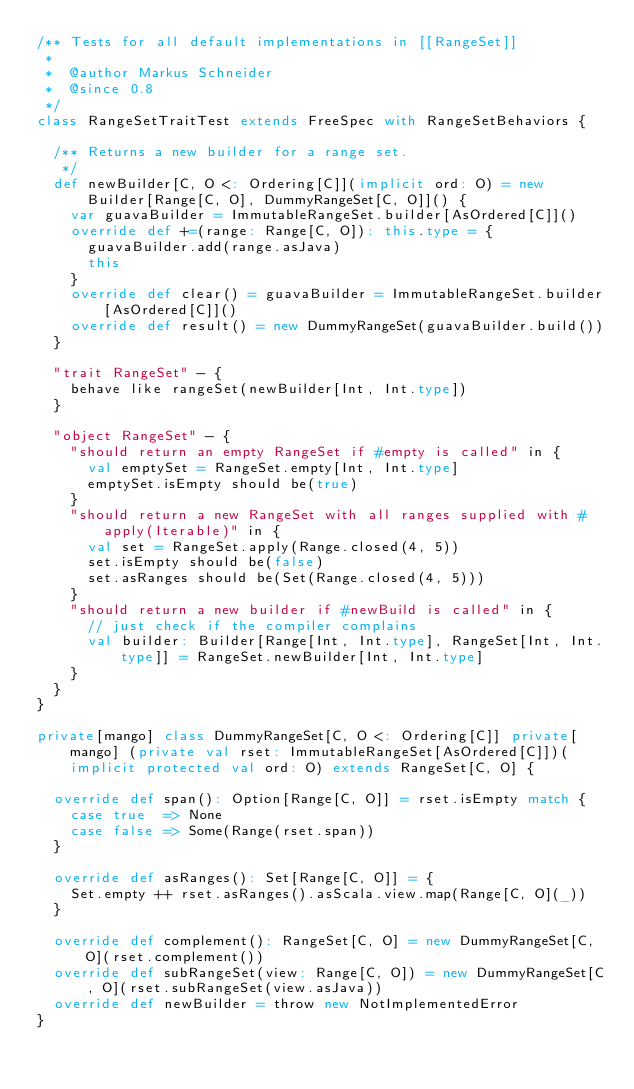Convert code to text. <code><loc_0><loc_0><loc_500><loc_500><_Scala_>/** Tests for all default implementations in [[RangeSet]]
 *
 *  @author Markus Schneider
 *  @since 0.8
 */
class RangeSetTraitTest extends FreeSpec with RangeSetBehaviors {

  /** Returns a new builder for a range set.
   */
  def newBuilder[C, O <: Ordering[C]](implicit ord: O) = new Builder[Range[C, O], DummyRangeSet[C, O]]() {
    var guavaBuilder = ImmutableRangeSet.builder[AsOrdered[C]]()
    override def +=(range: Range[C, O]): this.type = {
      guavaBuilder.add(range.asJava)
      this
    }
    override def clear() = guavaBuilder = ImmutableRangeSet.builder[AsOrdered[C]]()
    override def result() = new DummyRangeSet(guavaBuilder.build())
  }

  "trait RangeSet" - {
    behave like rangeSet(newBuilder[Int, Int.type])
  }

  "object RangeSet" - {
    "should return an empty RangeSet if #empty is called" in {
      val emptySet = RangeSet.empty[Int, Int.type]
      emptySet.isEmpty should be(true)
    }
    "should return a new RangeSet with all ranges supplied with #apply(Iterable)" in {
      val set = RangeSet.apply(Range.closed(4, 5))
      set.isEmpty should be(false)
      set.asRanges should be(Set(Range.closed(4, 5)))
    }
    "should return a new builder if #newBuild is called" in {
      // just check if the compiler complains
      val builder: Builder[Range[Int, Int.type], RangeSet[Int, Int.type]] = RangeSet.newBuilder[Int, Int.type]
    }
  }
}

private[mango] class DummyRangeSet[C, O <: Ordering[C]] private[mango] (private val rset: ImmutableRangeSet[AsOrdered[C]])(implicit protected val ord: O) extends RangeSet[C, O] {

  override def span(): Option[Range[C, O]] = rset.isEmpty match {
    case true  => None
    case false => Some(Range(rset.span))
  }

  override def asRanges(): Set[Range[C, O]] = {
    Set.empty ++ rset.asRanges().asScala.view.map(Range[C, O](_))
  }

  override def complement(): RangeSet[C, O] = new DummyRangeSet[C, O](rset.complement())
  override def subRangeSet(view: Range[C, O]) = new DummyRangeSet[C, O](rset.subRangeSet(view.asJava))
  override def newBuilder = throw new NotImplementedError
}

</code> 